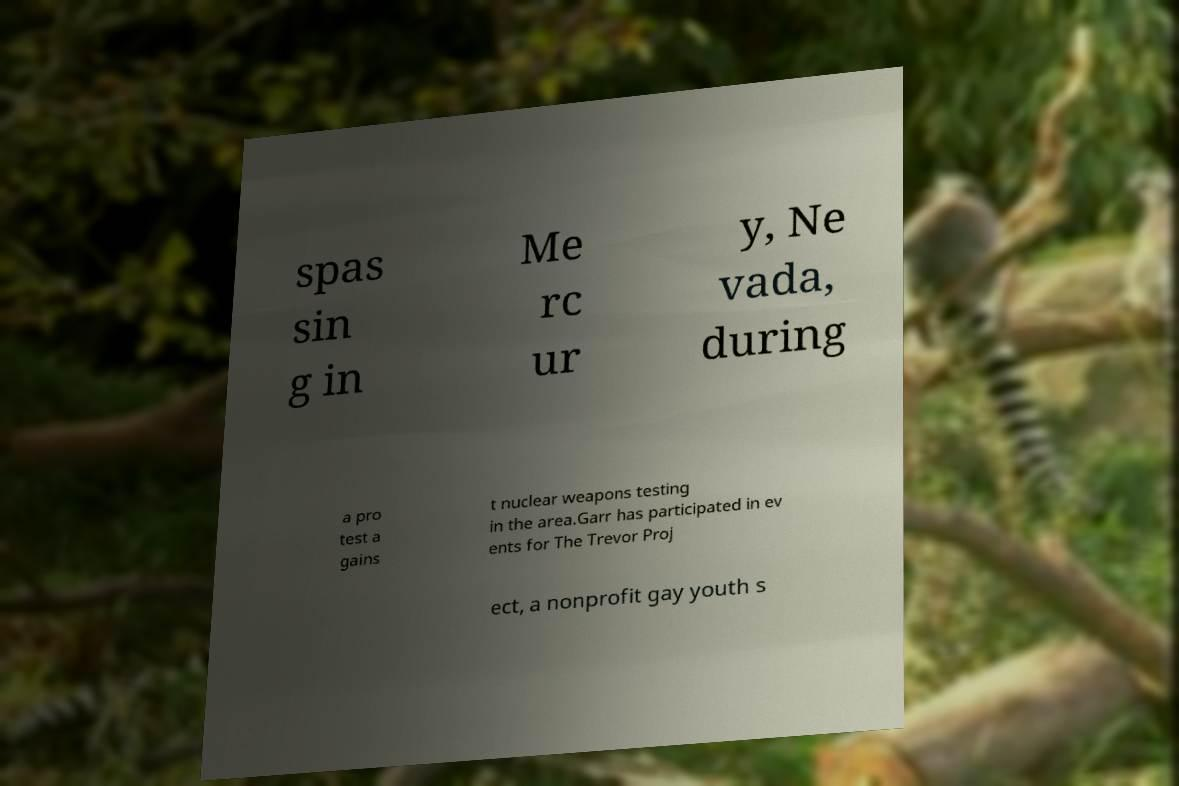There's text embedded in this image that I need extracted. Can you transcribe it verbatim? spas sin g in Me rc ur y, Ne vada, during a pro test a gains t nuclear weapons testing in the area.Garr has participated in ev ents for The Trevor Proj ect, a nonprofit gay youth s 